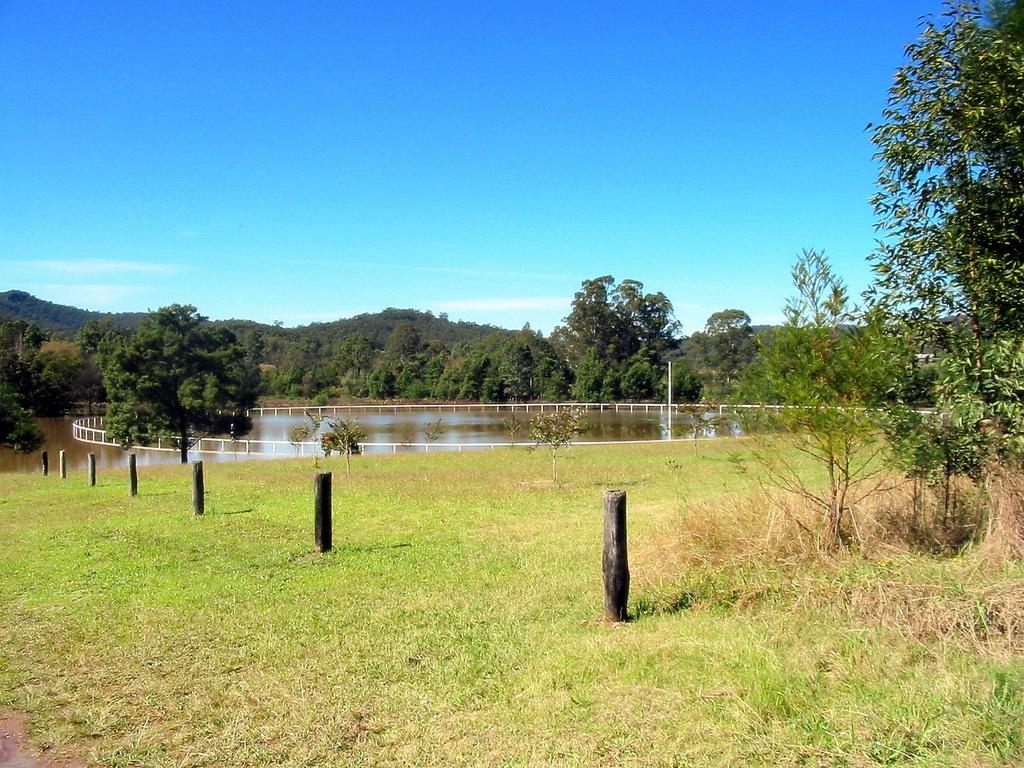What is arranged on the grass in the image? There are wooden sticks arranged in an order on the grass. What type of natural environment is visible in the image? There are trees and water visible in the image. What is the color of the railing in the image? The railing in the image is white. What is visible at the top of the image? The sky is visible at the top of the image. How does the jam move around in the image? There is no jam present in the image, so it cannot move around. 